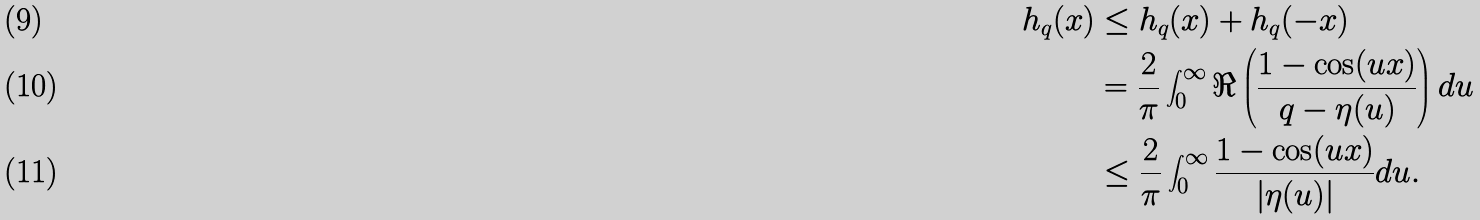Convert formula to latex. <formula><loc_0><loc_0><loc_500><loc_500>h _ { q } ( x ) & \leq h _ { q } ( x ) + h _ { q } ( - x ) \\ & = \frac { 2 } { \pi } \int ^ { \infty } _ { 0 } \Re \left ( \frac { 1 - \cos ( u x ) } { q - \eta ( u ) } \right ) d u \\ & \leq \frac { 2 } { \pi } \int ^ { \infty } _ { 0 } \frac { 1 - \cos ( u x ) } { | \eta ( u ) | } d u .</formula> 